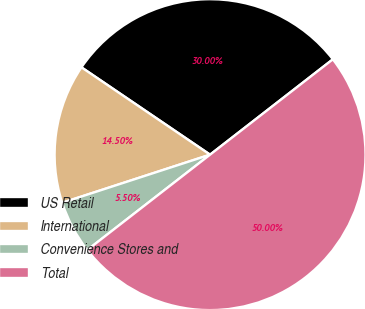Convert chart to OTSL. <chart><loc_0><loc_0><loc_500><loc_500><pie_chart><fcel>US Retail<fcel>International<fcel>Convenience Stores and<fcel>Total<nl><fcel>30.0%<fcel>14.5%<fcel>5.5%<fcel>50.0%<nl></chart> 